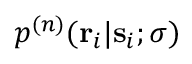<formula> <loc_0><loc_0><loc_500><loc_500>p ^ { ( n ) } ( r _ { i } | s _ { i } ; \sigma )</formula> 